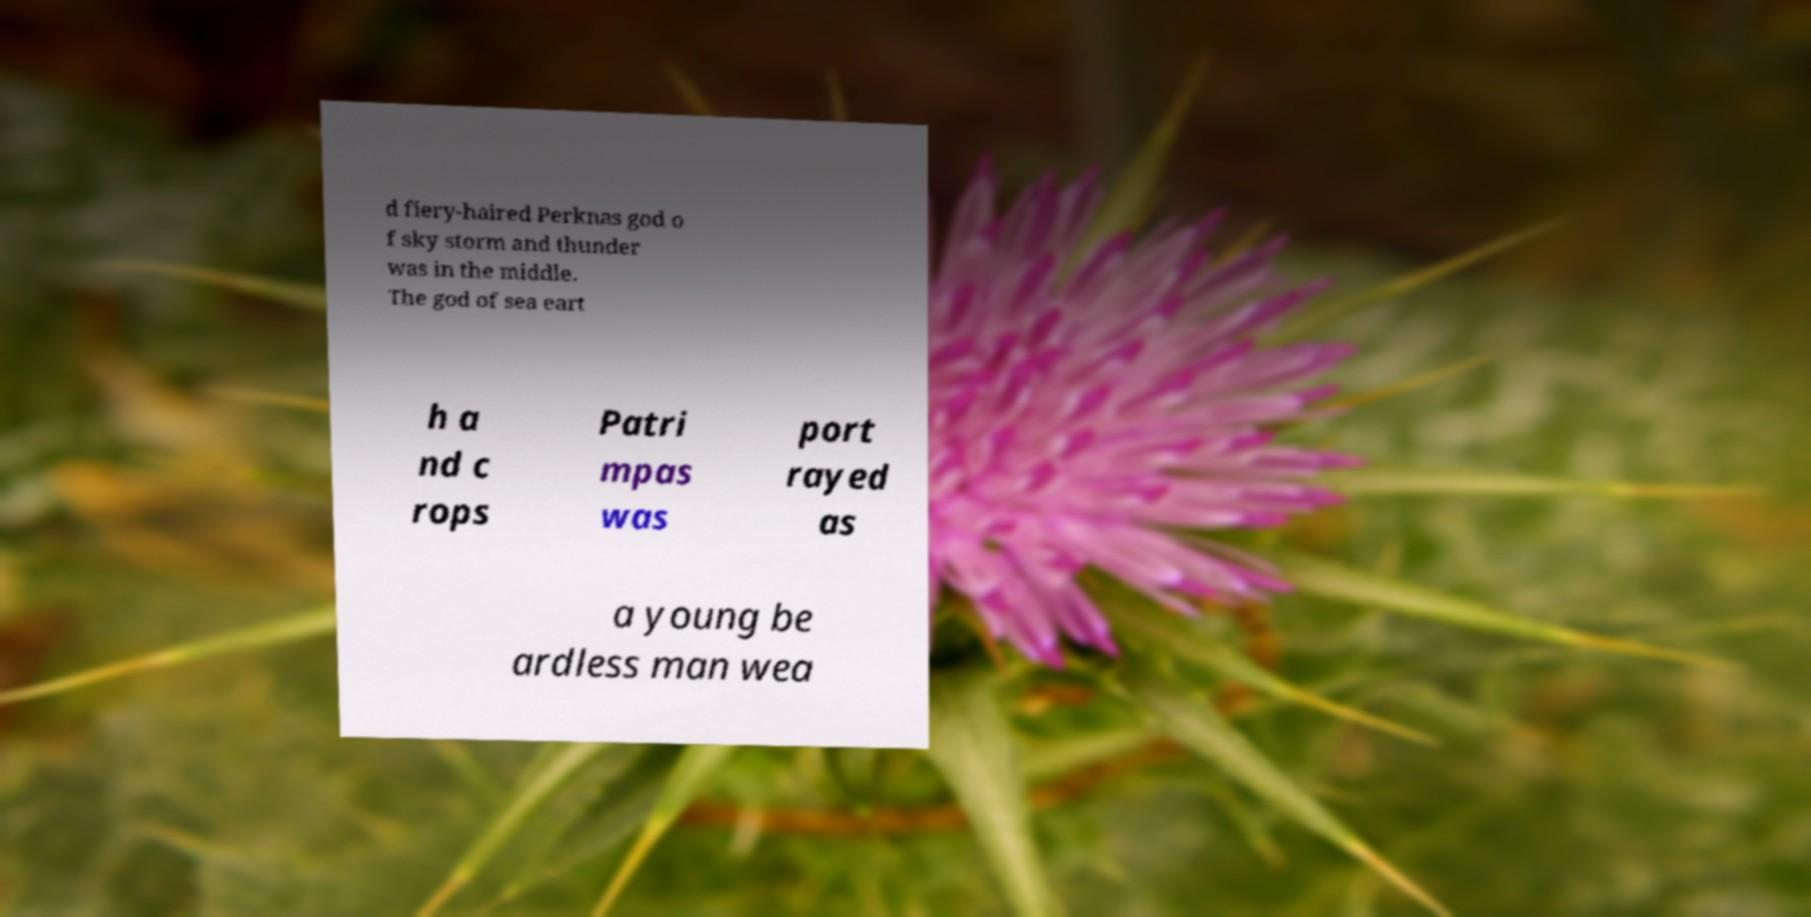For documentation purposes, I need the text within this image transcribed. Could you provide that? d fiery-haired Perknas god o f sky storm and thunder was in the middle. The god of sea eart h a nd c rops Patri mpas was port rayed as a young be ardless man wea 